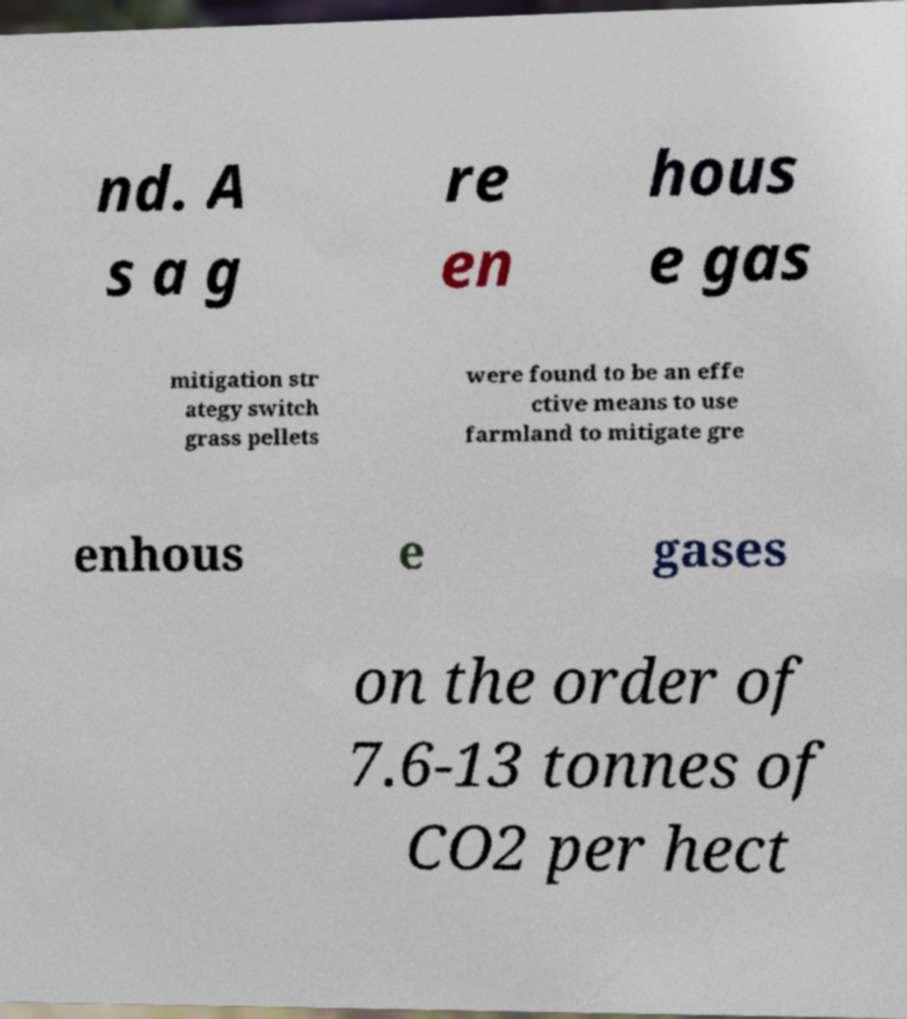Can you accurately transcribe the text from the provided image for me? nd. A s a g re en hous e gas mitigation str ategy switch grass pellets were found to be an effe ctive means to use farmland to mitigate gre enhous e gases on the order of 7.6-13 tonnes of CO2 per hect 